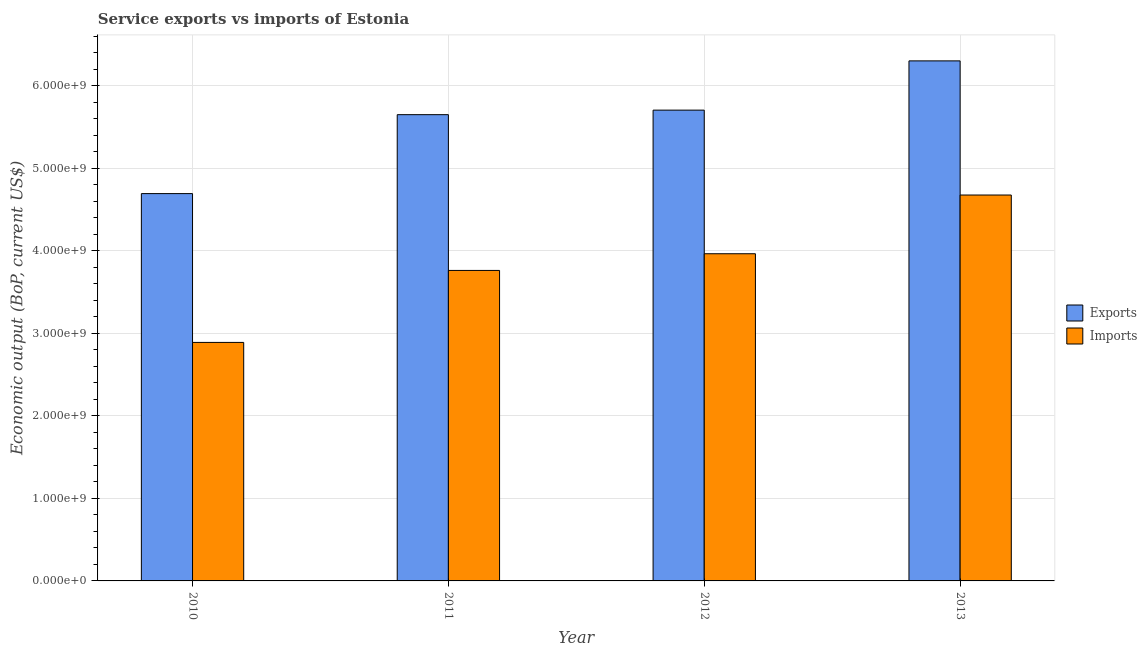How many groups of bars are there?
Your answer should be compact. 4. Are the number of bars on each tick of the X-axis equal?
Your answer should be very brief. Yes. How many bars are there on the 3rd tick from the left?
Your answer should be compact. 2. How many bars are there on the 3rd tick from the right?
Offer a very short reply. 2. In how many cases, is the number of bars for a given year not equal to the number of legend labels?
Your answer should be very brief. 0. What is the amount of service exports in 2013?
Provide a short and direct response. 6.30e+09. Across all years, what is the maximum amount of service imports?
Provide a succinct answer. 4.68e+09. Across all years, what is the minimum amount of service exports?
Provide a short and direct response. 4.69e+09. In which year was the amount of service imports maximum?
Keep it short and to the point. 2013. What is the total amount of service exports in the graph?
Keep it short and to the point. 2.24e+1. What is the difference between the amount of service imports in 2011 and that in 2013?
Your answer should be compact. -9.14e+08. What is the difference between the amount of service exports in 2013 and the amount of service imports in 2012?
Offer a very short reply. 5.97e+08. What is the average amount of service exports per year?
Your answer should be compact. 5.59e+09. In how many years, is the amount of service imports greater than 5000000000 US$?
Ensure brevity in your answer.  0. What is the ratio of the amount of service imports in 2012 to that in 2013?
Keep it short and to the point. 0.85. Is the amount of service imports in 2010 less than that in 2011?
Your answer should be compact. Yes. What is the difference between the highest and the second highest amount of service imports?
Offer a very short reply. 7.12e+08. What is the difference between the highest and the lowest amount of service exports?
Provide a succinct answer. 1.61e+09. Is the sum of the amount of service exports in 2012 and 2013 greater than the maximum amount of service imports across all years?
Provide a succinct answer. Yes. What does the 1st bar from the left in 2010 represents?
Provide a short and direct response. Exports. What does the 2nd bar from the right in 2010 represents?
Give a very brief answer. Exports. How many bars are there?
Provide a succinct answer. 8. How many years are there in the graph?
Your answer should be compact. 4. Are the values on the major ticks of Y-axis written in scientific E-notation?
Make the answer very short. Yes. Does the graph contain any zero values?
Your answer should be very brief. No. Does the graph contain grids?
Give a very brief answer. Yes. How many legend labels are there?
Your answer should be very brief. 2. What is the title of the graph?
Provide a short and direct response. Service exports vs imports of Estonia. Does "Age 65(female)" appear as one of the legend labels in the graph?
Ensure brevity in your answer.  No. What is the label or title of the X-axis?
Provide a short and direct response. Year. What is the label or title of the Y-axis?
Offer a very short reply. Economic output (BoP, current US$). What is the Economic output (BoP, current US$) in Exports in 2010?
Provide a succinct answer. 4.69e+09. What is the Economic output (BoP, current US$) in Imports in 2010?
Provide a short and direct response. 2.89e+09. What is the Economic output (BoP, current US$) in Exports in 2011?
Make the answer very short. 5.65e+09. What is the Economic output (BoP, current US$) of Imports in 2011?
Offer a terse response. 3.76e+09. What is the Economic output (BoP, current US$) in Exports in 2012?
Offer a terse response. 5.71e+09. What is the Economic output (BoP, current US$) of Imports in 2012?
Your answer should be very brief. 3.96e+09. What is the Economic output (BoP, current US$) in Exports in 2013?
Your response must be concise. 6.30e+09. What is the Economic output (BoP, current US$) in Imports in 2013?
Your answer should be very brief. 4.68e+09. Across all years, what is the maximum Economic output (BoP, current US$) of Exports?
Provide a succinct answer. 6.30e+09. Across all years, what is the maximum Economic output (BoP, current US$) of Imports?
Your answer should be compact. 4.68e+09. Across all years, what is the minimum Economic output (BoP, current US$) of Exports?
Offer a very short reply. 4.69e+09. Across all years, what is the minimum Economic output (BoP, current US$) of Imports?
Provide a succinct answer. 2.89e+09. What is the total Economic output (BoP, current US$) in Exports in the graph?
Offer a terse response. 2.24e+1. What is the total Economic output (BoP, current US$) in Imports in the graph?
Provide a short and direct response. 1.53e+1. What is the difference between the Economic output (BoP, current US$) in Exports in 2010 and that in 2011?
Your answer should be compact. -9.57e+08. What is the difference between the Economic output (BoP, current US$) in Imports in 2010 and that in 2011?
Keep it short and to the point. -8.72e+08. What is the difference between the Economic output (BoP, current US$) in Exports in 2010 and that in 2012?
Make the answer very short. -1.01e+09. What is the difference between the Economic output (BoP, current US$) of Imports in 2010 and that in 2012?
Provide a short and direct response. -1.07e+09. What is the difference between the Economic output (BoP, current US$) in Exports in 2010 and that in 2013?
Ensure brevity in your answer.  -1.61e+09. What is the difference between the Economic output (BoP, current US$) of Imports in 2010 and that in 2013?
Offer a very short reply. -1.79e+09. What is the difference between the Economic output (BoP, current US$) of Exports in 2011 and that in 2012?
Make the answer very short. -5.51e+07. What is the difference between the Economic output (BoP, current US$) in Imports in 2011 and that in 2012?
Your answer should be compact. -2.02e+08. What is the difference between the Economic output (BoP, current US$) in Exports in 2011 and that in 2013?
Your response must be concise. -6.52e+08. What is the difference between the Economic output (BoP, current US$) in Imports in 2011 and that in 2013?
Your answer should be compact. -9.14e+08. What is the difference between the Economic output (BoP, current US$) in Exports in 2012 and that in 2013?
Your response must be concise. -5.97e+08. What is the difference between the Economic output (BoP, current US$) of Imports in 2012 and that in 2013?
Ensure brevity in your answer.  -7.12e+08. What is the difference between the Economic output (BoP, current US$) of Exports in 2010 and the Economic output (BoP, current US$) of Imports in 2011?
Provide a succinct answer. 9.31e+08. What is the difference between the Economic output (BoP, current US$) of Exports in 2010 and the Economic output (BoP, current US$) of Imports in 2012?
Provide a short and direct response. 7.29e+08. What is the difference between the Economic output (BoP, current US$) of Exports in 2010 and the Economic output (BoP, current US$) of Imports in 2013?
Your response must be concise. 1.72e+07. What is the difference between the Economic output (BoP, current US$) of Exports in 2011 and the Economic output (BoP, current US$) of Imports in 2012?
Your answer should be very brief. 1.69e+09. What is the difference between the Economic output (BoP, current US$) of Exports in 2011 and the Economic output (BoP, current US$) of Imports in 2013?
Offer a terse response. 9.74e+08. What is the difference between the Economic output (BoP, current US$) in Exports in 2012 and the Economic output (BoP, current US$) in Imports in 2013?
Provide a succinct answer. 1.03e+09. What is the average Economic output (BoP, current US$) of Exports per year?
Your response must be concise. 5.59e+09. What is the average Economic output (BoP, current US$) in Imports per year?
Offer a terse response. 3.82e+09. In the year 2010, what is the difference between the Economic output (BoP, current US$) of Exports and Economic output (BoP, current US$) of Imports?
Provide a short and direct response. 1.80e+09. In the year 2011, what is the difference between the Economic output (BoP, current US$) in Exports and Economic output (BoP, current US$) in Imports?
Give a very brief answer. 1.89e+09. In the year 2012, what is the difference between the Economic output (BoP, current US$) of Exports and Economic output (BoP, current US$) of Imports?
Provide a succinct answer. 1.74e+09. In the year 2013, what is the difference between the Economic output (BoP, current US$) of Exports and Economic output (BoP, current US$) of Imports?
Make the answer very short. 1.63e+09. What is the ratio of the Economic output (BoP, current US$) in Exports in 2010 to that in 2011?
Offer a very short reply. 0.83. What is the ratio of the Economic output (BoP, current US$) of Imports in 2010 to that in 2011?
Offer a very short reply. 0.77. What is the ratio of the Economic output (BoP, current US$) of Exports in 2010 to that in 2012?
Give a very brief answer. 0.82. What is the ratio of the Economic output (BoP, current US$) in Imports in 2010 to that in 2012?
Make the answer very short. 0.73. What is the ratio of the Economic output (BoP, current US$) in Exports in 2010 to that in 2013?
Your response must be concise. 0.74. What is the ratio of the Economic output (BoP, current US$) in Imports in 2010 to that in 2013?
Provide a succinct answer. 0.62. What is the ratio of the Economic output (BoP, current US$) of Exports in 2011 to that in 2012?
Keep it short and to the point. 0.99. What is the ratio of the Economic output (BoP, current US$) in Imports in 2011 to that in 2012?
Your answer should be very brief. 0.95. What is the ratio of the Economic output (BoP, current US$) in Exports in 2011 to that in 2013?
Give a very brief answer. 0.9. What is the ratio of the Economic output (BoP, current US$) in Imports in 2011 to that in 2013?
Keep it short and to the point. 0.8. What is the ratio of the Economic output (BoP, current US$) in Exports in 2012 to that in 2013?
Your response must be concise. 0.91. What is the ratio of the Economic output (BoP, current US$) in Imports in 2012 to that in 2013?
Give a very brief answer. 0.85. What is the difference between the highest and the second highest Economic output (BoP, current US$) in Exports?
Keep it short and to the point. 5.97e+08. What is the difference between the highest and the second highest Economic output (BoP, current US$) in Imports?
Give a very brief answer. 7.12e+08. What is the difference between the highest and the lowest Economic output (BoP, current US$) of Exports?
Provide a succinct answer. 1.61e+09. What is the difference between the highest and the lowest Economic output (BoP, current US$) in Imports?
Your response must be concise. 1.79e+09. 